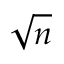<formula> <loc_0><loc_0><loc_500><loc_500>\sqrt { n }</formula> 